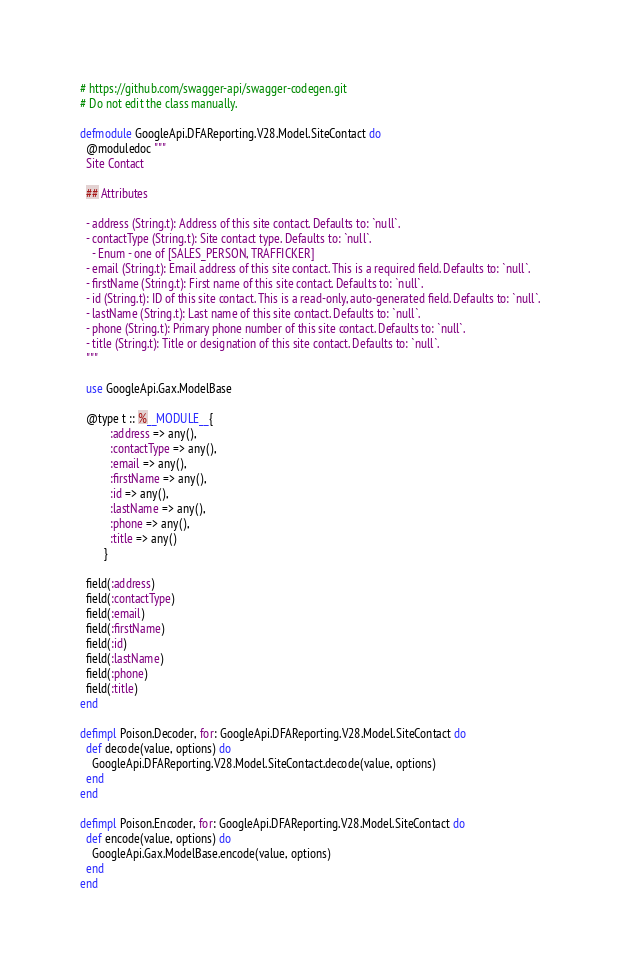<code> <loc_0><loc_0><loc_500><loc_500><_Elixir_># https://github.com/swagger-api/swagger-codegen.git
# Do not edit the class manually.

defmodule GoogleApi.DFAReporting.V28.Model.SiteContact do
  @moduledoc """
  Site Contact

  ## Attributes

  - address (String.t): Address of this site contact. Defaults to: `null`.
  - contactType (String.t): Site contact type. Defaults to: `null`.
    - Enum - one of [SALES_PERSON, TRAFFICKER]
  - email (String.t): Email address of this site contact. This is a required field. Defaults to: `null`.
  - firstName (String.t): First name of this site contact. Defaults to: `null`.
  - id (String.t): ID of this site contact. This is a read-only, auto-generated field. Defaults to: `null`.
  - lastName (String.t): Last name of this site contact. Defaults to: `null`.
  - phone (String.t): Primary phone number of this site contact. Defaults to: `null`.
  - title (String.t): Title or designation of this site contact. Defaults to: `null`.
  """

  use GoogleApi.Gax.ModelBase

  @type t :: %__MODULE__{
          :address => any(),
          :contactType => any(),
          :email => any(),
          :firstName => any(),
          :id => any(),
          :lastName => any(),
          :phone => any(),
          :title => any()
        }

  field(:address)
  field(:contactType)
  field(:email)
  field(:firstName)
  field(:id)
  field(:lastName)
  field(:phone)
  field(:title)
end

defimpl Poison.Decoder, for: GoogleApi.DFAReporting.V28.Model.SiteContact do
  def decode(value, options) do
    GoogleApi.DFAReporting.V28.Model.SiteContact.decode(value, options)
  end
end

defimpl Poison.Encoder, for: GoogleApi.DFAReporting.V28.Model.SiteContact do
  def encode(value, options) do
    GoogleApi.Gax.ModelBase.encode(value, options)
  end
end
</code> 